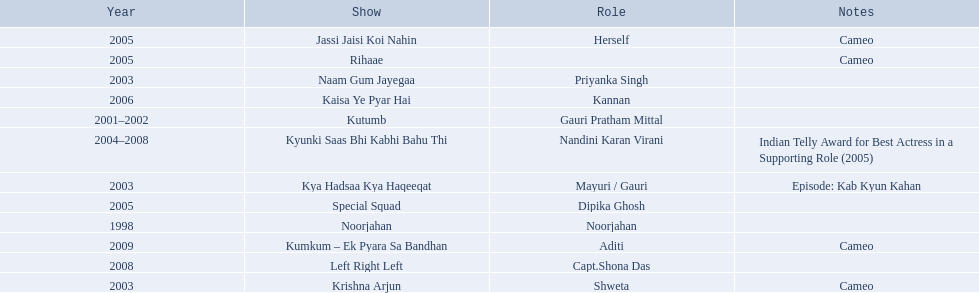What shows was gauri tejwani in? Noorjahan, Kutumb, Krishna Arjun, Naam Gum Jayegaa, Kya Hadsaa Kya Haqeeqat, Kyunki Saas Bhi Kabhi Bahu Thi, Rihaae, Jassi Jaisi Koi Nahin, Special Squad, Kaisa Ye Pyar Hai, Left Right Left, Kumkum – Ek Pyara Sa Bandhan. What were the 2005 shows? Rihaae, Jassi Jaisi Koi Nahin, Special Squad. Which were cameos? Rihaae, Jassi Jaisi Koi Nahin. Of which of these it was not rihaee? Jassi Jaisi Koi Nahin. 